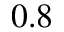<formula> <loc_0><loc_0><loc_500><loc_500>0 . 8</formula> 